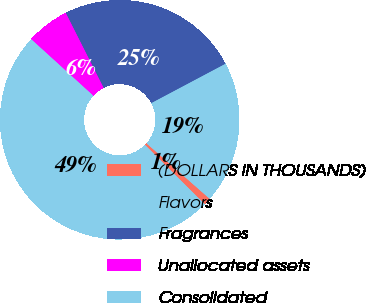Convert chart. <chart><loc_0><loc_0><loc_500><loc_500><pie_chart><fcel>(DOLLARS IN THOUSANDS)<fcel>Flavors<fcel>Fragrances<fcel>Unallocated assets<fcel>Consolidated<nl><fcel>0.98%<fcel>19.23%<fcel>24.68%<fcel>5.81%<fcel>49.29%<nl></chart> 